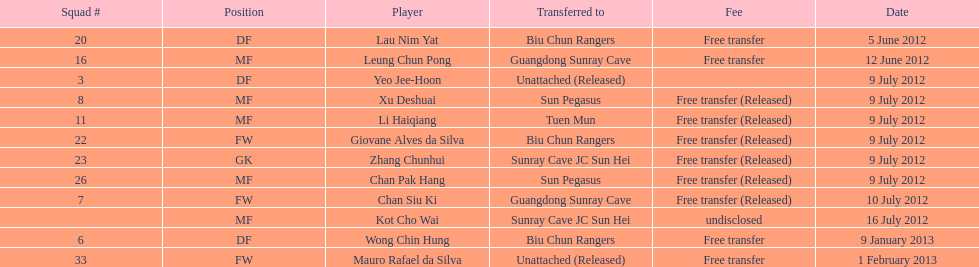Li haiqiang and xu deshuai both played which position? MF. I'm looking to parse the entire table for insights. Could you assist me with that? {'header': ['Squad #', 'Position', 'Player', 'Transferred to', 'Fee', 'Date'], 'rows': [['20', 'DF', 'Lau Nim Yat', 'Biu Chun Rangers', 'Free transfer', '5 June 2012'], ['16', 'MF', 'Leung Chun Pong', 'Guangdong Sunray Cave', 'Free transfer', '12 June 2012'], ['3', 'DF', 'Yeo Jee-Hoon', 'Unattached (Released)', '', '9 July 2012'], ['8', 'MF', 'Xu Deshuai', 'Sun Pegasus', 'Free transfer (Released)', '9 July 2012'], ['11', 'MF', 'Li Haiqiang', 'Tuen Mun', 'Free transfer (Released)', '9 July 2012'], ['22', 'FW', 'Giovane Alves da Silva', 'Biu Chun Rangers', 'Free transfer (Released)', '9 July 2012'], ['23', 'GK', 'Zhang Chunhui', 'Sunray Cave JC Sun Hei', 'Free transfer (Released)', '9 July 2012'], ['26', 'MF', 'Chan Pak Hang', 'Sun Pegasus', 'Free transfer (Released)', '9 July 2012'], ['7', 'FW', 'Chan Siu Ki', 'Guangdong Sunray Cave', 'Free transfer (Released)', '10 July 2012'], ['', 'MF', 'Kot Cho Wai', 'Sunray Cave JC Sun Hei', 'undisclosed', '16 July 2012'], ['6', 'DF', 'Wong Chin Hung', 'Biu Chun Rangers', 'Free transfer', '9 January 2013'], ['33', 'FW', 'Mauro Rafael da Silva', 'Unattached (Released)', 'Free transfer', '1 February 2013']]} 